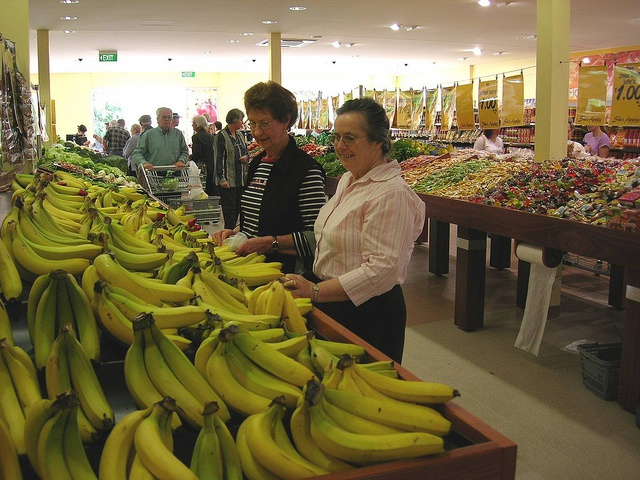Describe the objects in this image and their specific colors. I can see banana in olive and black tones, people in olive, gray, black, tan, and maroon tones, people in olive, black, maroon, and gray tones, banana in olive and black tones, and banana in olive and black tones in this image. 